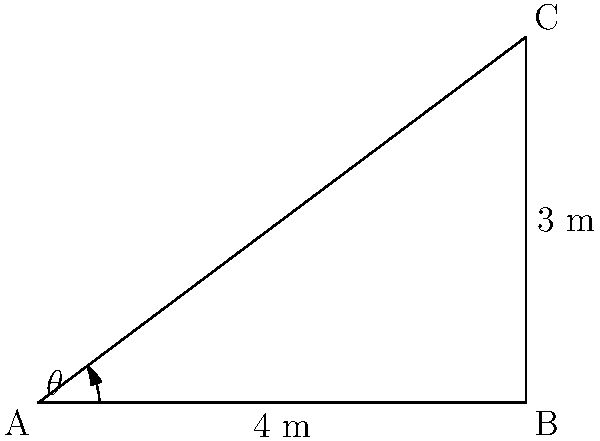In your manufacturing process, a robotic arm needs to move from point A to point C. The arm's base is at point A, and it needs to reach a component at point C. The horizontal distance (AB) is 4 meters, and the vertical distance (BC) is 3 meters. What is the optimal angle $\theta$ (in degrees) that the robotic arm should rotate to reach the component efficiently? To find the optimal angle for the robotic arm's movement, we need to use trigonometry. Let's approach this step-by-step:

1) We have a right-angled triangle ABC, where:
   - AB is the horizontal distance = 4 meters
   - BC is the vertical distance = 3 meters
   - AC is the hypotenuse (direct path from A to C)
   - $\theta$ is the angle we need to calculate

2) In a right-angled triangle, we can use the tangent function to find the angle:

   $\tan(\theta) = \frac{\text{opposite}}{\text{adjacent}} = \frac{BC}{AB} = \frac{3}{4}$

3) To find $\theta$, we need to use the inverse tangent (arctangent) function:

   $\theta = \arctan(\frac{3}{4})$

4) Using a calculator or programming function, we can compute this value:

   $\theta \approx 36.87°$

5) Round to two decimal places for practical application in the PLC system.

Therefore, the optimal angle for the robotic arm to rotate is approximately 36.87°.
Answer: 36.87° 